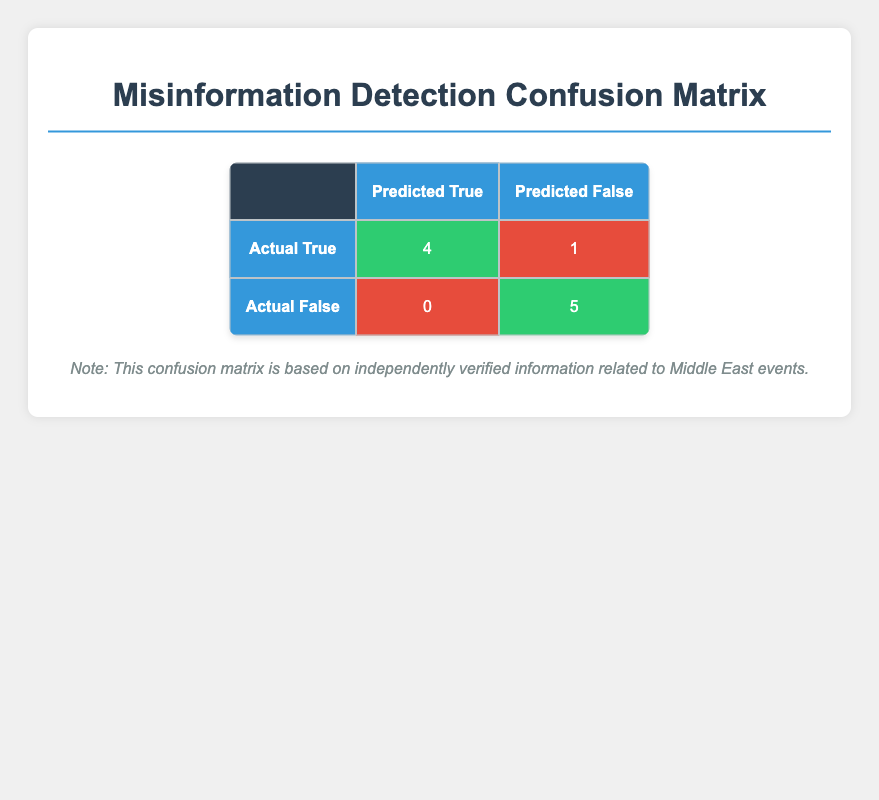What is the number of true positives in the confusion matrix? The "True Positive" is found in the first row and the first column of the matrix, which states there are 4 cases.
Answer: 4 What is the number of false negatives in the confusion matrix? The "False Negative" is located in the first row and the second column, which shows there is 1 case.
Answer: 1 How many times did the model predict misinformation when it was actually true? This is referred to as "False Positives," which is in the second row and the first column. The table shows there are 0 cases.
Answer: 0 What is the total number of posts that were actually misinformation? Misinformation can be found in the second row for "Actual False," which states there are 5 true negatives plus 0 false positives. The table shows 5 misinformation cases.
Answer: 5 If we combine false positives and false negatives, what is the total? The total can be found by adding false positives (0) and false negatives (1), which gives a sum of 1.
Answer: 1 What percentage of posts that were actually true were correctly identified? To find this, take the number of true positives (4) and divide it by the total number of actual true posts (4 + 1 = 5). Calculating (4/5)*100 gives us 80%.
Answer: 80% Did the model identify all misinformation cases correctly? Checking the table, we find that the predicted values for the actual false posts (5 true negatives) indicate that it did not make any false positive predictions, but there's a false negative indicating it missed one true case. Therefore, the answer is no.
Answer: No What is the ratio of true negatives to false positives? The number of true negatives is 5, and false positives is 0. The ratio is therefore 5 to 0, but since division by zero is undefined, we note this as simply indicating there are no false positives, meaning all negative predictions were correct.
Answer: Undefined (or simply 5:0 indicating no false positives) What does the confusion matrix suggest about the model's reliability in detecting misinformation? The model has a high number of true positives and true negatives (4 and 5, respectively), with no false positives and only 1 false negative. This suggests a reliable performance in identifying misinformation.
Answer: The model is reliable 